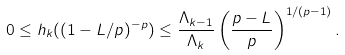Convert formula to latex. <formula><loc_0><loc_0><loc_500><loc_500>0 \leq h _ { k } ( ( 1 - L / p ) ^ { - p } ) \leq \frac { \Lambda _ { k - 1 } } { \Lambda _ { k } } \left ( \frac { p - L } { p } \right ) ^ { 1 / ( p - 1 ) } .</formula> 